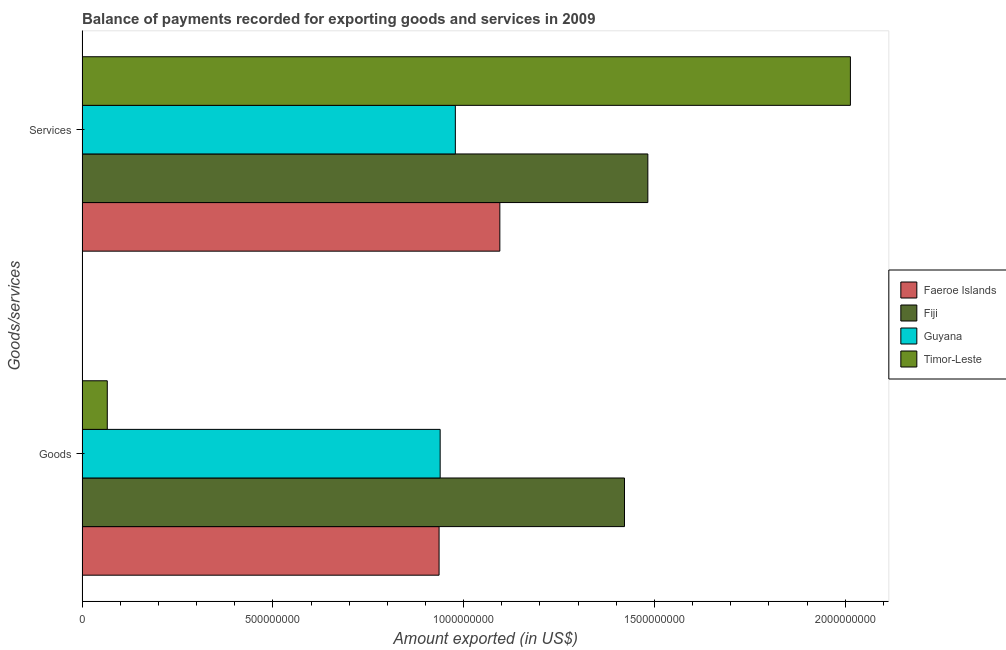How many different coloured bars are there?
Provide a succinct answer. 4. Are the number of bars per tick equal to the number of legend labels?
Your answer should be very brief. Yes. How many bars are there on the 2nd tick from the top?
Keep it short and to the point. 4. How many bars are there on the 2nd tick from the bottom?
Offer a very short reply. 4. What is the label of the 2nd group of bars from the top?
Offer a very short reply. Goods. What is the amount of services exported in Faeroe Islands?
Your response must be concise. 1.09e+09. Across all countries, what is the maximum amount of services exported?
Offer a very short reply. 2.01e+09. Across all countries, what is the minimum amount of goods exported?
Keep it short and to the point. 6.61e+07. In which country was the amount of goods exported maximum?
Provide a succinct answer. Fiji. In which country was the amount of goods exported minimum?
Your answer should be very brief. Timor-Leste. What is the total amount of goods exported in the graph?
Give a very brief answer. 3.36e+09. What is the difference between the amount of services exported in Fiji and that in Guyana?
Provide a short and direct response. 5.04e+08. What is the difference between the amount of goods exported in Guyana and the amount of services exported in Fiji?
Your response must be concise. -5.44e+08. What is the average amount of services exported per country?
Your response must be concise. 1.39e+09. What is the difference between the amount of goods exported and amount of services exported in Guyana?
Give a very brief answer. -3.98e+07. In how many countries, is the amount of services exported greater than 600000000 US$?
Provide a succinct answer. 4. What is the ratio of the amount of goods exported in Fiji to that in Guyana?
Provide a short and direct response. 1.51. What does the 2nd bar from the top in Goods represents?
Provide a succinct answer. Guyana. What does the 3rd bar from the bottom in Goods represents?
Keep it short and to the point. Guyana. How many bars are there?
Your answer should be very brief. 8. Are all the bars in the graph horizontal?
Provide a short and direct response. Yes. How many countries are there in the graph?
Offer a very short reply. 4. Are the values on the major ticks of X-axis written in scientific E-notation?
Your answer should be compact. No. How many legend labels are there?
Ensure brevity in your answer.  4. How are the legend labels stacked?
Your answer should be compact. Vertical. What is the title of the graph?
Offer a very short reply. Balance of payments recorded for exporting goods and services in 2009. What is the label or title of the X-axis?
Keep it short and to the point. Amount exported (in US$). What is the label or title of the Y-axis?
Your answer should be very brief. Goods/services. What is the Amount exported (in US$) of Faeroe Islands in Goods?
Your answer should be very brief. 9.36e+08. What is the Amount exported (in US$) in Fiji in Goods?
Keep it short and to the point. 1.42e+09. What is the Amount exported (in US$) in Guyana in Goods?
Offer a terse response. 9.38e+08. What is the Amount exported (in US$) in Timor-Leste in Goods?
Offer a very short reply. 6.61e+07. What is the Amount exported (in US$) in Faeroe Islands in Services?
Your answer should be compact. 1.09e+09. What is the Amount exported (in US$) in Fiji in Services?
Your response must be concise. 1.48e+09. What is the Amount exported (in US$) of Guyana in Services?
Ensure brevity in your answer.  9.78e+08. What is the Amount exported (in US$) in Timor-Leste in Services?
Your answer should be compact. 2.01e+09. Across all Goods/services, what is the maximum Amount exported (in US$) in Faeroe Islands?
Make the answer very short. 1.09e+09. Across all Goods/services, what is the maximum Amount exported (in US$) of Fiji?
Give a very brief answer. 1.48e+09. Across all Goods/services, what is the maximum Amount exported (in US$) of Guyana?
Your answer should be compact. 9.78e+08. Across all Goods/services, what is the maximum Amount exported (in US$) of Timor-Leste?
Your answer should be compact. 2.01e+09. Across all Goods/services, what is the minimum Amount exported (in US$) of Faeroe Islands?
Keep it short and to the point. 9.36e+08. Across all Goods/services, what is the minimum Amount exported (in US$) in Fiji?
Give a very brief answer. 1.42e+09. Across all Goods/services, what is the minimum Amount exported (in US$) in Guyana?
Offer a very short reply. 9.38e+08. Across all Goods/services, what is the minimum Amount exported (in US$) of Timor-Leste?
Offer a very short reply. 6.61e+07. What is the total Amount exported (in US$) in Faeroe Islands in the graph?
Offer a very short reply. 2.03e+09. What is the total Amount exported (in US$) in Fiji in the graph?
Keep it short and to the point. 2.90e+09. What is the total Amount exported (in US$) of Guyana in the graph?
Your answer should be very brief. 1.92e+09. What is the total Amount exported (in US$) of Timor-Leste in the graph?
Make the answer very short. 2.08e+09. What is the difference between the Amount exported (in US$) in Faeroe Islands in Goods and that in Services?
Keep it short and to the point. -1.59e+08. What is the difference between the Amount exported (in US$) in Fiji in Goods and that in Services?
Your response must be concise. -6.12e+07. What is the difference between the Amount exported (in US$) of Guyana in Goods and that in Services?
Provide a short and direct response. -3.98e+07. What is the difference between the Amount exported (in US$) of Timor-Leste in Goods and that in Services?
Provide a short and direct response. -1.95e+09. What is the difference between the Amount exported (in US$) of Faeroe Islands in Goods and the Amount exported (in US$) of Fiji in Services?
Offer a terse response. -5.47e+08. What is the difference between the Amount exported (in US$) of Faeroe Islands in Goods and the Amount exported (in US$) of Guyana in Services?
Your response must be concise. -4.26e+07. What is the difference between the Amount exported (in US$) of Faeroe Islands in Goods and the Amount exported (in US$) of Timor-Leste in Services?
Make the answer very short. -1.08e+09. What is the difference between the Amount exported (in US$) in Fiji in Goods and the Amount exported (in US$) in Guyana in Services?
Your answer should be very brief. 4.43e+08. What is the difference between the Amount exported (in US$) of Fiji in Goods and the Amount exported (in US$) of Timor-Leste in Services?
Provide a succinct answer. -5.92e+08. What is the difference between the Amount exported (in US$) of Guyana in Goods and the Amount exported (in US$) of Timor-Leste in Services?
Your response must be concise. -1.08e+09. What is the average Amount exported (in US$) in Faeroe Islands per Goods/services?
Make the answer very short. 1.02e+09. What is the average Amount exported (in US$) in Fiji per Goods/services?
Give a very brief answer. 1.45e+09. What is the average Amount exported (in US$) in Guyana per Goods/services?
Your response must be concise. 9.58e+08. What is the average Amount exported (in US$) in Timor-Leste per Goods/services?
Your answer should be very brief. 1.04e+09. What is the difference between the Amount exported (in US$) in Faeroe Islands and Amount exported (in US$) in Fiji in Goods?
Your response must be concise. -4.86e+08. What is the difference between the Amount exported (in US$) in Faeroe Islands and Amount exported (in US$) in Guyana in Goods?
Your answer should be compact. -2.84e+06. What is the difference between the Amount exported (in US$) of Faeroe Islands and Amount exported (in US$) of Timor-Leste in Goods?
Your answer should be compact. 8.70e+08. What is the difference between the Amount exported (in US$) of Fiji and Amount exported (in US$) of Guyana in Goods?
Your answer should be compact. 4.83e+08. What is the difference between the Amount exported (in US$) of Fiji and Amount exported (in US$) of Timor-Leste in Goods?
Provide a succinct answer. 1.36e+09. What is the difference between the Amount exported (in US$) in Guyana and Amount exported (in US$) in Timor-Leste in Goods?
Provide a short and direct response. 8.72e+08. What is the difference between the Amount exported (in US$) of Faeroe Islands and Amount exported (in US$) of Fiji in Services?
Your answer should be very brief. -3.88e+08. What is the difference between the Amount exported (in US$) of Faeroe Islands and Amount exported (in US$) of Guyana in Services?
Provide a succinct answer. 1.17e+08. What is the difference between the Amount exported (in US$) in Faeroe Islands and Amount exported (in US$) in Timor-Leste in Services?
Make the answer very short. -9.19e+08. What is the difference between the Amount exported (in US$) in Fiji and Amount exported (in US$) in Guyana in Services?
Give a very brief answer. 5.04e+08. What is the difference between the Amount exported (in US$) in Fiji and Amount exported (in US$) in Timor-Leste in Services?
Ensure brevity in your answer.  -5.31e+08. What is the difference between the Amount exported (in US$) of Guyana and Amount exported (in US$) of Timor-Leste in Services?
Give a very brief answer. -1.04e+09. What is the ratio of the Amount exported (in US$) of Faeroe Islands in Goods to that in Services?
Your answer should be compact. 0.85. What is the ratio of the Amount exported (in US$) of Fiji in Goods to that in Services?
Give a very brief answer. 0.96. What is the ratio of the Amount exported (in US$) of Guyana in Goods to that in Services?
Provide a succinct answer. 0.96. What is the ratio of the Amount exported (in US$) of Timor-Leste in Goods to that in Services?
Offer a very short reply. 0.03. What is the difference between the highest and the second highest Amount exported (in US$) in Faeroe Islands?
Ensure brevity in your answer.  1.59e+08. What is the difference between the highest and the second highest Amount exported (in US$) in Fiji?
Keep it short and to the point. 6.12e+07. What is the difference between the highest and the second highest Amount exported (in US$) in Guyana?
Your answer should be compact. 3.98e+07. What is the difference between the highest and the second highest Amount exported (in US$) in Timor-Leste?
Your response must be concise. 1.95e+09. What is the difference between the highest and the lowest Amount exported (in US$) in Faeroe Islands?
Give a very brief answer. 1.59e+08. What is the difference between the highest and the lowest Amount exported (in US$) of Fiji?
Ensure brevity in your answer.  6.12e+07. What is the difference between the highest and the lowest Amount exported (in US$) in Guyana?
Keep it short and to the point. 3.98e+07. What is the difference between the highest and the lowest Amount exported (in US$) of Timor-Leste?
Your answer should be very brief. 1.95e+09. 